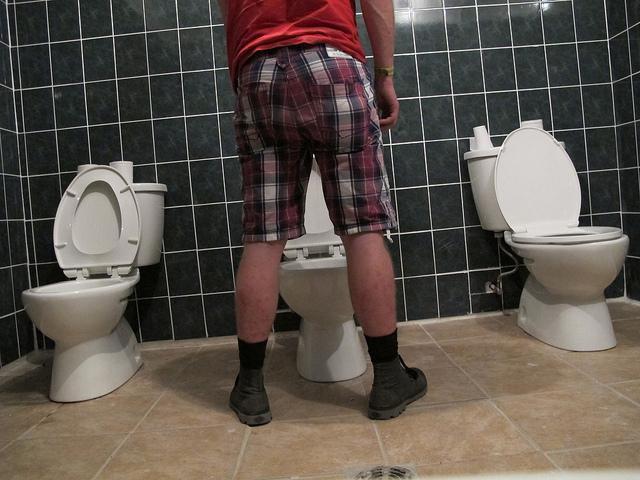Which room is this?
Indicate the correct response and explain using: 'Answer: answer
Rationale: rationale.'
Options: Ball, kitchen, men's restroom, ladies room. Answer: men's restroom.
Rationale: It appears to be a given the lifted seats and the form of the figure in the middle. 